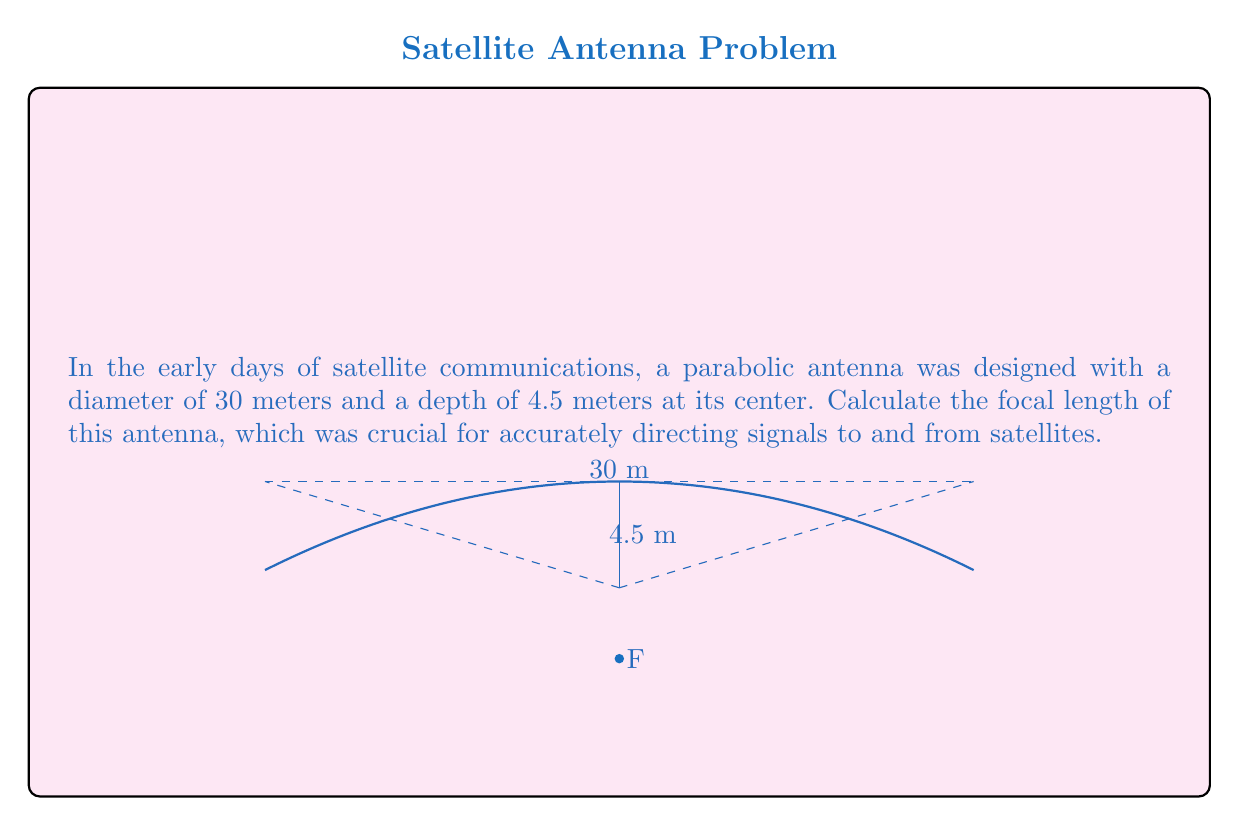Could you help me with this problem? To solve this problem, we'll use the properties of a parabola and the given dimensions of the antenna.

1) The equation of a parabola with vertex at the origin and opening upward is:

   $$y = \frac{1}{4f}x^2$$

   where $f$ is the focal length.

2) For our antenna, we need to consider it opening downward, so our equation becomes:

   $$y = -\frac{1}{4f}x^2$$

3) We know two points on this parabola:
   - The vertex: (0, 0)
   - The edge point: (15, -4.5), as the radius is half the diameter (30/2 = 15)

4) Let's substitute the edge point into our equation:

   $$-4.5 = -\frac{1}{4f}(15)^2$$

5) Solve for $f$:

   $$4.5 = \frac{225}{4f}$$
   $$18f = 225$$
   $$f = \frac{225}{18} = 12.5$$

6) Therefore, the focal length of the antenna is 12.5 meters.

This focal length is crucial for the antenna's performance. The feed horn, which receives or transmits the signal, would be placed at this focal point to maximize the efficiency of the antenna in communicating with satellites.
Answer: $12.5$ meters 